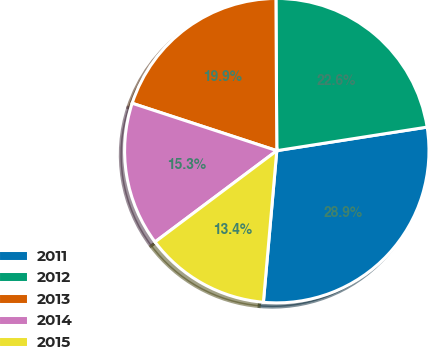Convert chart to OTSL. <chart><loc_0><loc_0><loc_500><loc_500><pie_chart><fcel>2011<fcel>2012<fcel>2013<fcel>2014<fcel>2015<nl><fcel>28.88%<fcel>22.62%<fcel>19.87%<fcel>15.28%<fcel>13.36%<nl></chart> 